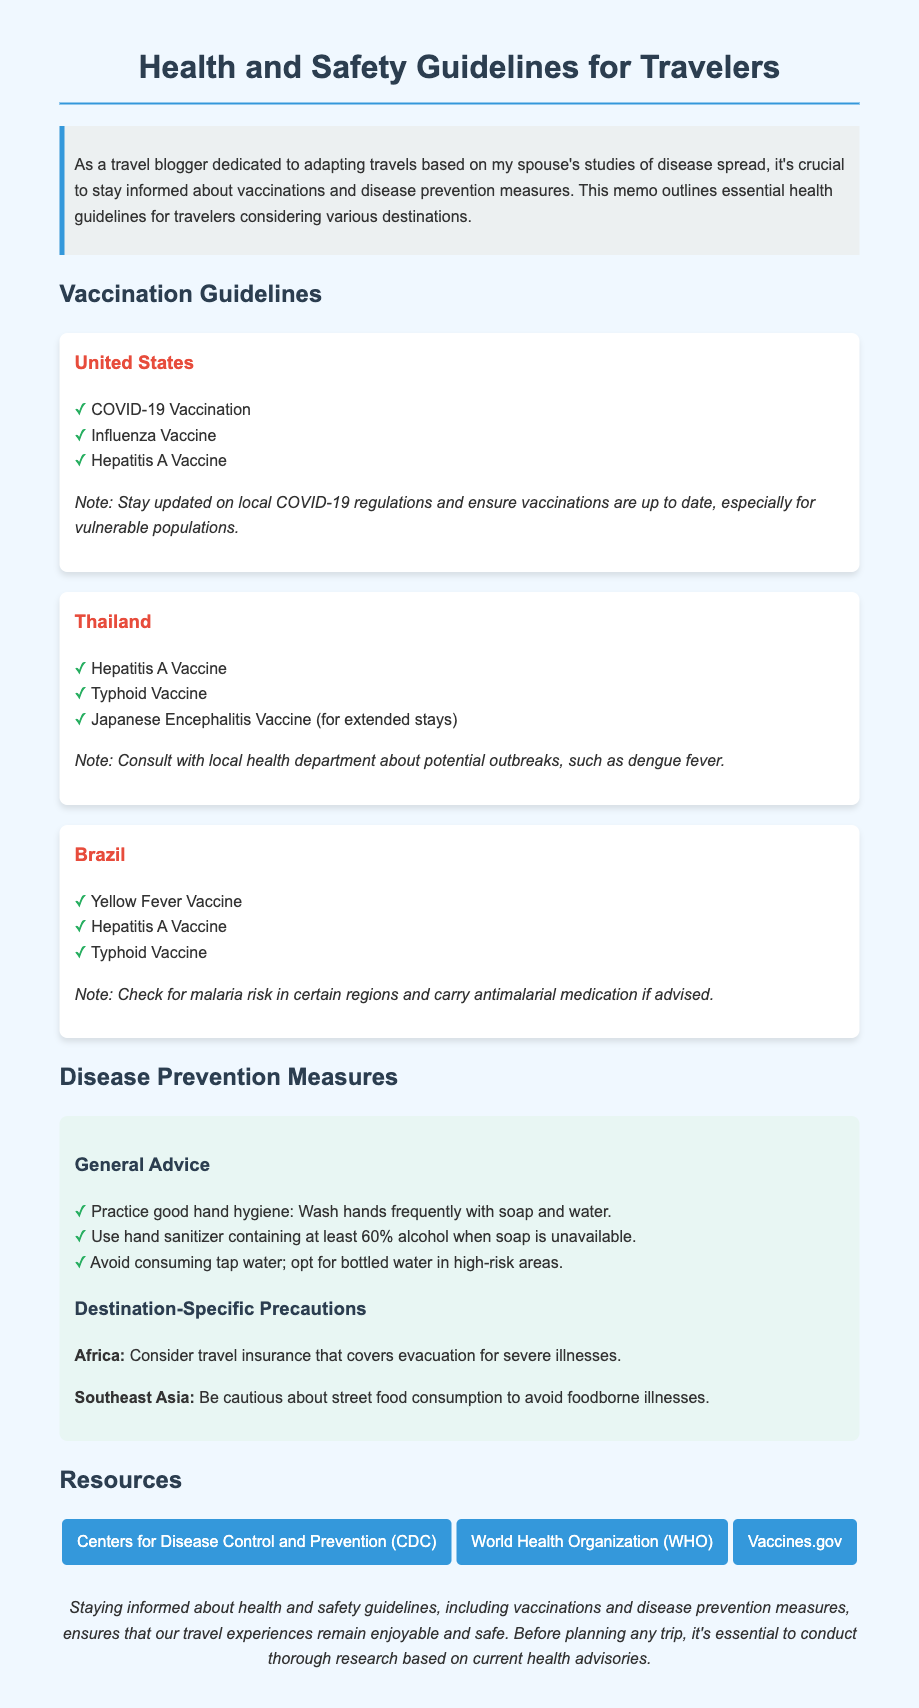What vaccines are recommended for travelers to the United States? The United States section lists the recommended vaccines as COVID-19 Vaccination, Influenza Vaccine, and Hepatitis A Vaccine.
Answer: COVID-19 Vaccination, Influenza Vaccine, Hepatitis A Vaccine What specific vaccine is noted for extended stays in Thailand? The vaccine recommended for extended stays in Thailand is the Japanese Encephalitis Vaccine.
Answer: Japanese Encephalitis Vaccine What general advice is given for hand hygiene? The document suggests practicing good hand hygiene by washing hands frequently with soap and water.
Answer: Wash hands frequently with soap and water Which continent is advised to consider travel insurance for severe illnesses? The document mentions that Africa should consider travel insurance that covers evacuation for severe illnesses.
Answer: Africa How many links are provided in the Resources section? The document presents three links in the Resources section.
Answer: Three Which vaccine is specifically mentioned for Brazil and is used for prevention against a specific disease? The vaccination card for Brazil specifies the Yellow Fever Vaccine, which is used to prevent Yellow Fever.
Answer: Yellow Fever Vaccine What precaution is highlighted for Southeast Asia regarding food consumption? The memo warns to be cautious about street food consumption to avoid foodborne illnesses in Southeast Asia.
Answer: Street food consumption What is the purpose of this memo? The purpose is to outline essential health guidelines for travelers considering various destinations, focusing on vaccinations and disease prevention.
Answer: Essential health guidelines for travelers Which organization provides guidance on travel health safety according to the resources? The Centers for Disease Control and Prevention (CDC) provides guidance as noted in the resources section.
Answer: Centers for Disease Control and Prevention (CDC) 